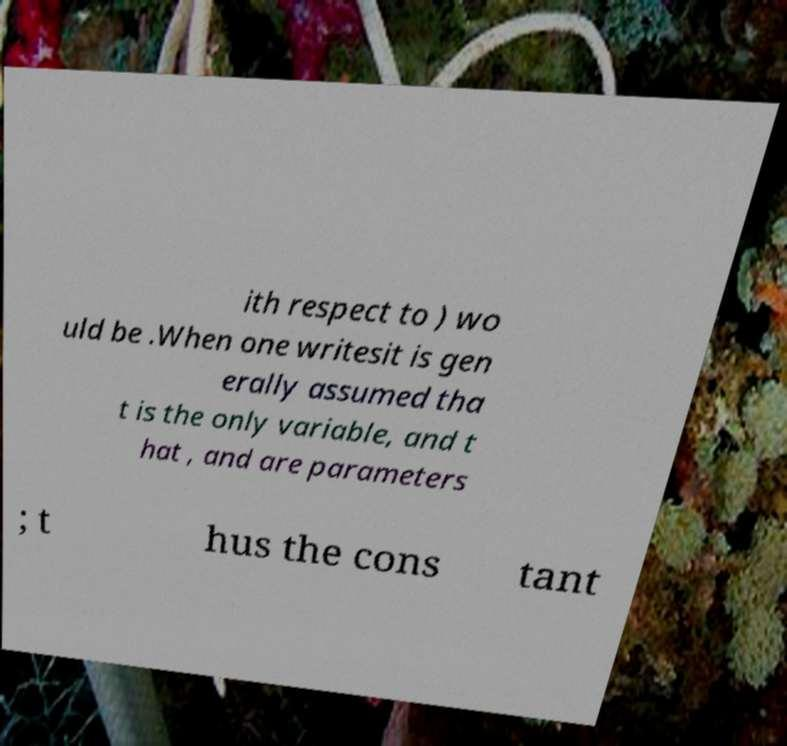I need the written content from this picture converted into text. Can you do that? ith respect to ) wo uld be .When one writesit is gen erally assumed tha t is the only variable, and t hat , and are parameters ; t hus the cons tant 